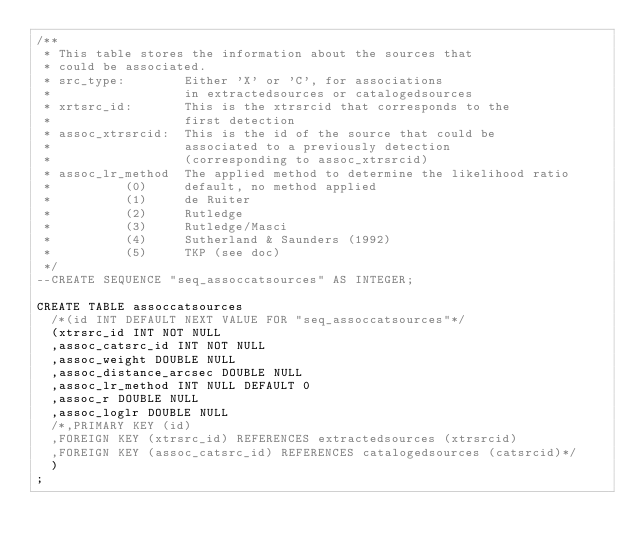Convert code to text. <code><loc_0><loc_0><loc_500><loc_500><_SQL_>/**
 * This table stores the information about the sources that
 * could be associated.
 * src_type:        Either 'X' or 'C', for associations 
 *                  in extractedsources or catalogedsources
 * xrtsrc_id:       This is the xtrsrcid that corresponds to the 
 *                  first detection
 * assoc_xtrsrcid:  This is the id of the source that could be 
 *                  associated to a previously detection 
 *                  (corresponding to assoc_xtrsrcid)
 * assoc_lr_method  The applied method to determine the likelihood ratio 
 *          (0)     default, no method applied
 *          (1)     de Ruiter
 *          (2)     Rutledge
 *          (3)     Rutledge/Masci
 *          (4)     Sutherland & Saunders (1992)
 *          (5)     TKP (see doc)
 */
--CREATE SEQUENCE "seq_assoccatsources" AS INTEGER;

CREATE TABLE assoccatsources
  /*(id INT DEFAULT NEXT VALUE FOR "seq_assoccatsources"*/
  (xtrsrc_id INT NOT NULL
  ,assoc_catsrc_id INT NOT NULL
  ,assoc_weight DOUBLE NULL
  ,assoc_distance_arcsec DOUBLE NULL
  ,assoc_lr_method INT NULL DEFAULT 0
  ,assoc_r DOUBLE NULL
  ,assoc_loglr DOUBLE NULL
  /*,PRIMARY KEY (id)
  ,FOREIGN KEY (xtrsrc_id) REFERENCES extractedsources (xtrsrcid)
  ,FOREIGN KEY (assoc_catsrc_id) REFERENCES catalogedsources (catsrcid)*/
  )
;

</code> 